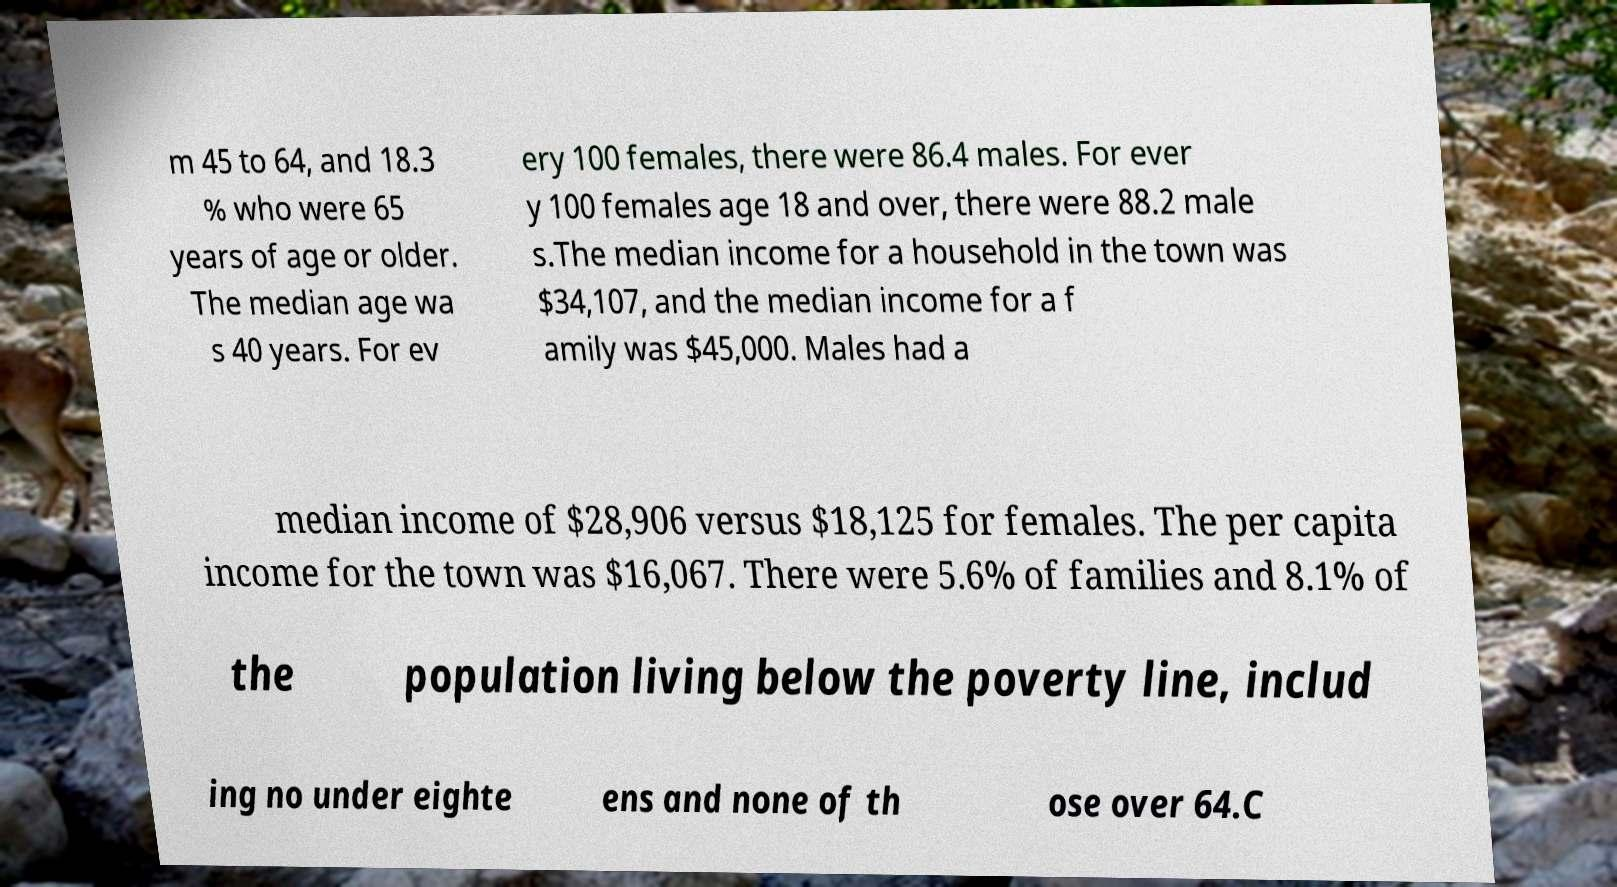Could you extract and type out the text from this image? m 45 to 64, and 18.3 % who were 65 years of age or older. The median age wa s 40 years. For ev ery 100 females, there were 86.4 males. For ever y 100 females age 18 and over, there were 88.2 male s.The median income for a household in the town was $34,107, and the median income for a f amily was $45,000. Males had a median income of $28,906 versus $18,125 for females. The per capita income for the town was $16,067. There were 5.6% of families and 8.1% of the population living below the poverty line, includ ing no under eighte ens and none of th ose over 64.C 